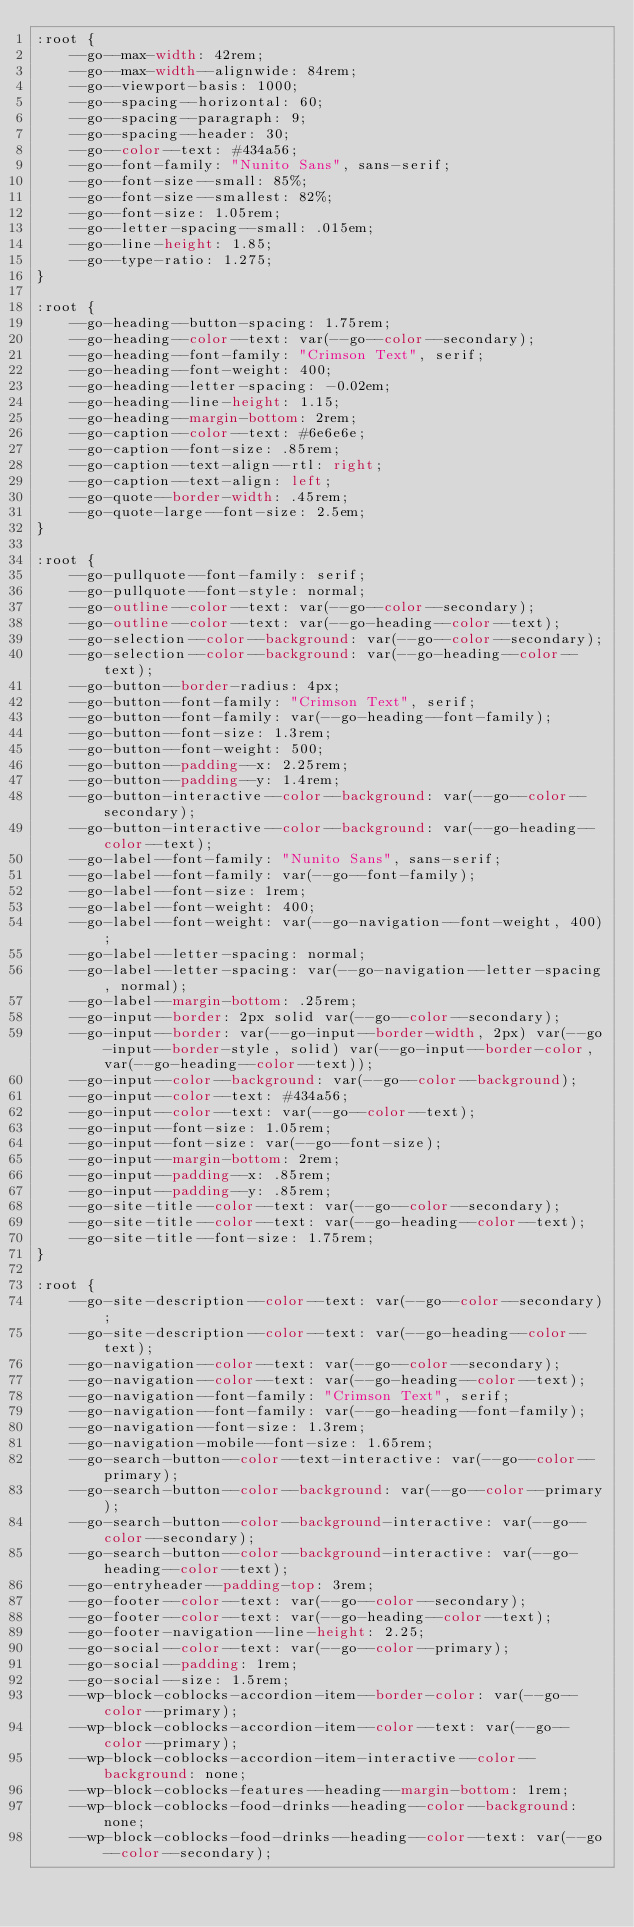Convert code to text. <code><loc_0><loc_0><loc_500><loc_500><_CSS_>:root {
    --go--max-width: 42rem;
    --go--max-width--alignwide: 84rem;
    --go--viewport-basis: 1000;
    --go--spacing--horizontal: 60;
    --go--spacing--paragraph: 9;
    --go--spacing--header: 30;
    --go--color--text: #434a56;
    --go--font-family: "Nunito Sans", sans-serif;
    --go--font-size--small: 85%;
    --go--font-size--smallest: 82%;
    --go--font-size: 1.05rem;
    --go--letter-spacing--small: .015em;
    --go--line-height: 1.85;
    --go--type-ratio: 1.275;
}

:root {
    --go-heading--button-spacing: 1.75rem;
    --go-heading--color--text: var(--go--color--secondary);
    --go-heading--font-family: "Crimson Text", serif;
    --go-heading--font-weight: 400;
    --go-heading--letter-spacing: -0.02em;
    --go-heading--line-height: 1.15;
    --go-heading--margin-bottom: 2rem;
    --go-caption--color--text: #6e6e6e;
    --go-caption--font-size: .85rem;
    --go-caption--text-align--rtl: right;
    --go-caption--text-align: left;
    --go-quote--border-width: .45rem;
    --go-quote-large--font-size: 2.5em;
}

:root {
    --go-pullquote--font-family: serif;
    --go-pullquote--font-style: normal;
    --go-outline--color--text: var(--go--color--secondary);
    --go-outline--color--text: var(--go-heading--color--text);
    --go-selection--color--background: var(--go--color--secondary);
    --go-selection--color--background: var(--go-heading--color--text);
    --go-button--border-radius: 4px;
    --go-button--font-family: "Crimson Text", serif;
    --go-button--font-family: var(--go-heading--font-family);
    --go-button--font-size: 1.3rem;
    --go-button--font-weight: 500;
    --go-button--padding--x: 2.25rem;
    --go-button--padding--y: 1.4rem;
    --go-button-interactive--color--background: var(--go--color--secondary);
    --go-button-interactive--color--background: var(--go-heading--color--text);
    --go-label--font-family: "Nunito Sans", sans-serif;
    --go-label--font-family: var(--go--font-family);
    --go-label--font-size: 1rem;
    --go-label--font-weight: 400;
    --go-label--font-weight: var(--go-navigation--font-weight, 400);
    --go-label--letter-spacing: normal;
    --go-label--letter-spacing: var(--go-navigation--letter-spacing, normal);
    --go-label--margin-bottom: .25rem;
    --go-input--border: 2px solid var(--go--color--secondary);
    --go-input--border: var(--go-input--border-width, 2px) var(--go-input--border-style, solid) var(--go-input--border-color, var(--go-heading--color--text));
    --go-input--color--background: var(--go--color--background);
    --go-input--color--text: #434a56;
    --go-input--color--text: var(--go--color--text);
    --go-input--font-size: 1.05rem;
    --go-input--font-size: var(--go--font-size);
    --go-input--margin-bottom: 2rem;
    --go-input--padding--x: .85rem;
    --go-input--padding--y: .85rem;
    --go-site-title--color--text: var(--go--color--secondary);
    --go-site-title--color--text: var(--go-heading--color--text);
    --go-site-title--font-size: 1.75rem;
}

:root {
    --go-site-description--color--text: var(--go--color--secondary);
    --go-site-description--color--text: var(--go-heading--color--text);
    --go-navigation--color--text: var(--go--color--secondary);
    --go-navigation--color--text: var(--go-heading--color--text);
    --go-navigation--font-family: "Crimson Text", serif;
    --go-navigation--font-family: var(--go-heading--font-family);
    --go-navigation--font-size: 1.3rem;
    --go-navigation-mobile--font-size: 1.65rem;
    --go-search-button--color--text-interactive: var(--go--color--primary);
    --go-search-button--color--background: var(--go--color--primary);
    --go-search-button--color--background-interactive: var(--go--color--secondary);
    --go-search-button--color--background-interactive: var(--go-heading--color--text);
    --go-entryheader--padding-top: 3rem;
    --go-footer--color--text: var(--go--color--secondary);
    --go-footer--color--text: var(--go-heading--color--text);
    --go-footer-navigation--line-height: 2.25;
    --go-social--color--text: var(--go--color--primary);
    --go-social--padding: 1rem;
    --go-social--size: 1.5rem;
    --wp-block-coblocks-accordion-item--border-color: var(--go--color--primary);
    --wp-block-coblocks-accordion-item--color--text: var(--go--color--primary);
    --wp-block-coblocks-accordion-item-interactive--color--background: none;
    --wp-block-coblocks-features--heading--margin-bottom: 1rem;
    --wp-block-coblocks-food-drinks--heading--color--background: none;
    --wp-block-coblocks-food-drinks--heading--color--text: var(--go--color--secondary);</code> 